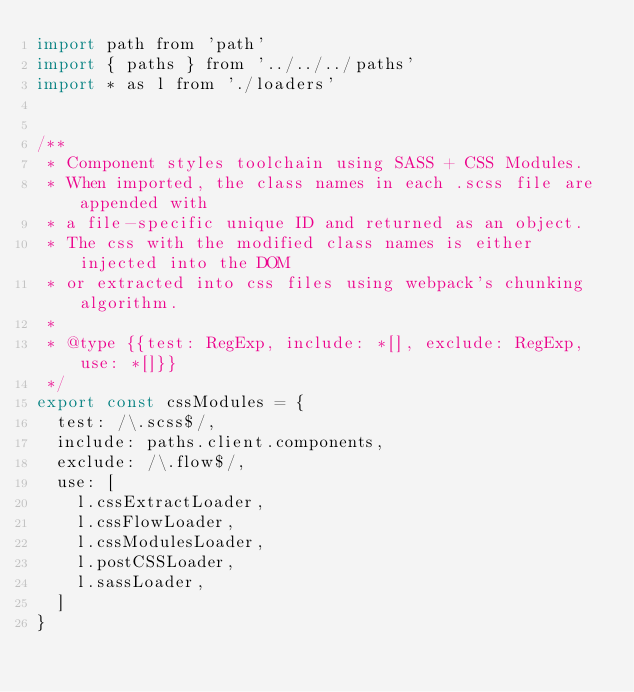<code> <loc_0><loc_0><loc_500><loc_500><_JavaScript_>import path from 'path'
import { paths } from '../../../paths'
import * as l from './loaders'


/**
 * Component styles toolchain using SASS + CSS Modules.
 * When imported, the class names in each .scss file are appended with
 * a file-specific unique ID and returned as an object.
 * The css with the modified class names is either injected into the DOM
 * or extracted into css files using webpack's chunking algorithm.
 *
 * @type {{test: RegExp, include: *[], exclude: RegExp, use: *[]}}
 */
export const cssModules = {
  test: /\.scss$/,
  include: paths.client.components,
  exclude: /\.flow$/,
  use: [
    l.cssExtractLoader,
    l.cssFlowLoader,
    l.cssModulesLoader,
    l.postCSSLoader,
    l.sassLoader,
  ]
}
</code> 